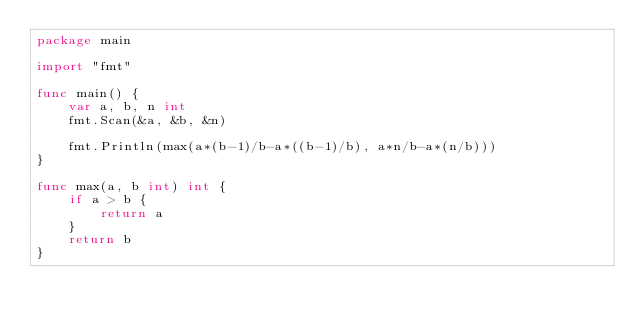<code> <loc_0><loc_0><loc_500><loc_500><_Go_>package main

import "fmt"

func main() {
	var a, b, n int
	fmt.Scan(&a, &b, &n)

	fmt.Println(max(a*(b-1)/b-a*((b-1)/b), a*n/b-a*(n/b)))
}

func max(a, b int) int {
	if a > b {
		return a
	}
	return b
}</code> 